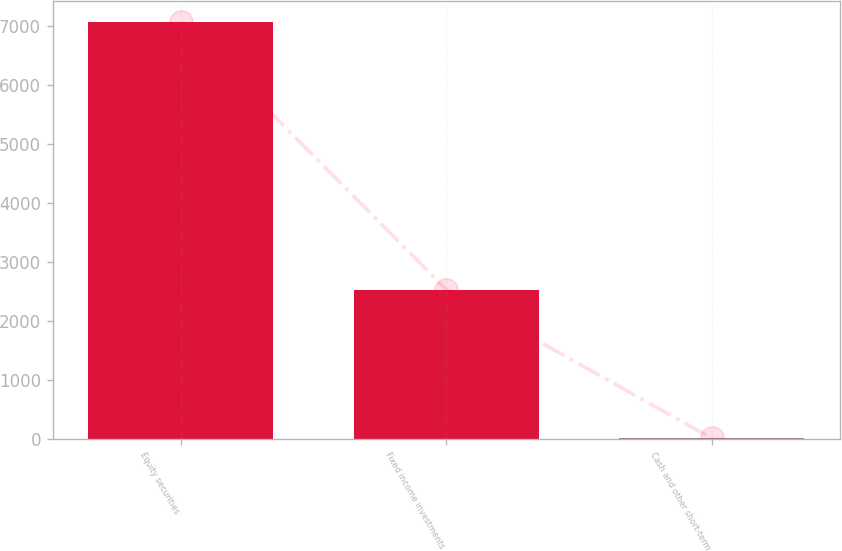Convert chart. <chart><loc_0><loc_0><loc_500><loc_500><bar_chart><fcel>Equity securities<fcel>Fixed income investments<fcel>Cash and other short-term<nl><fcel>7075<fcel>2530<fcel>5<nl></chart> 